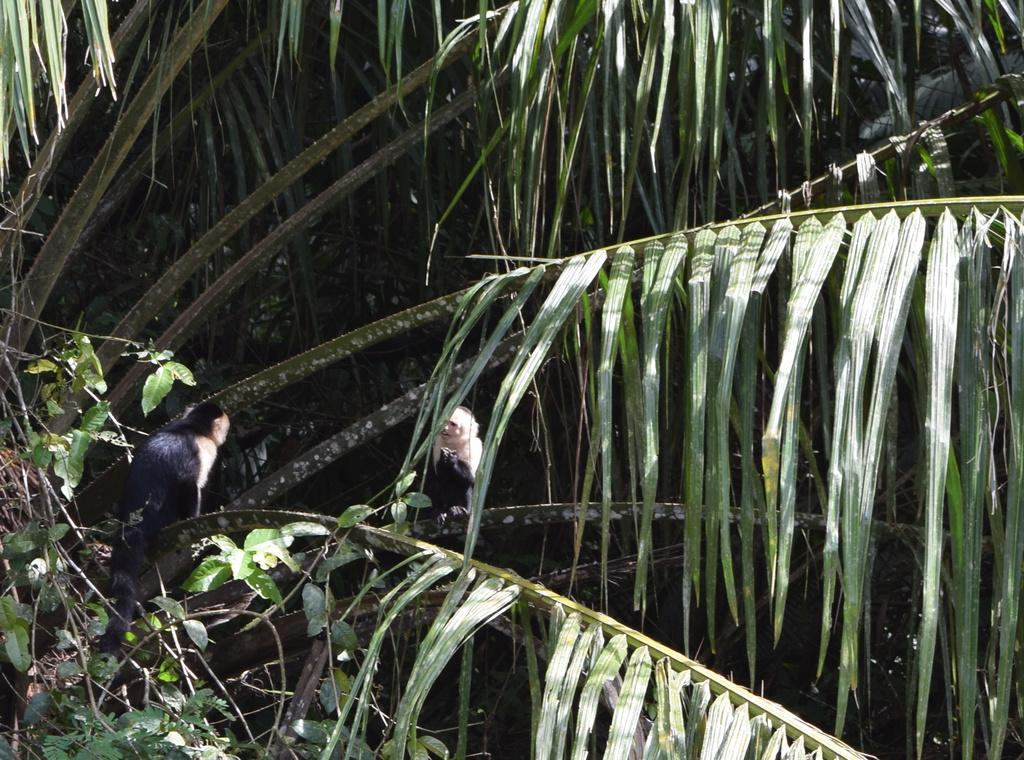What animals are in the center of the image? There are two monkeys in the center of the image. What can be seen in the background of the image? There is a tree in the background of the image. Where are the leaves located in the image? Leaves are present at the bottom left corner of the image. What color is the sheet that the monkeys are sitting on in the image? There is no sheet present in the image; the monkeys are not sitting on anything. 